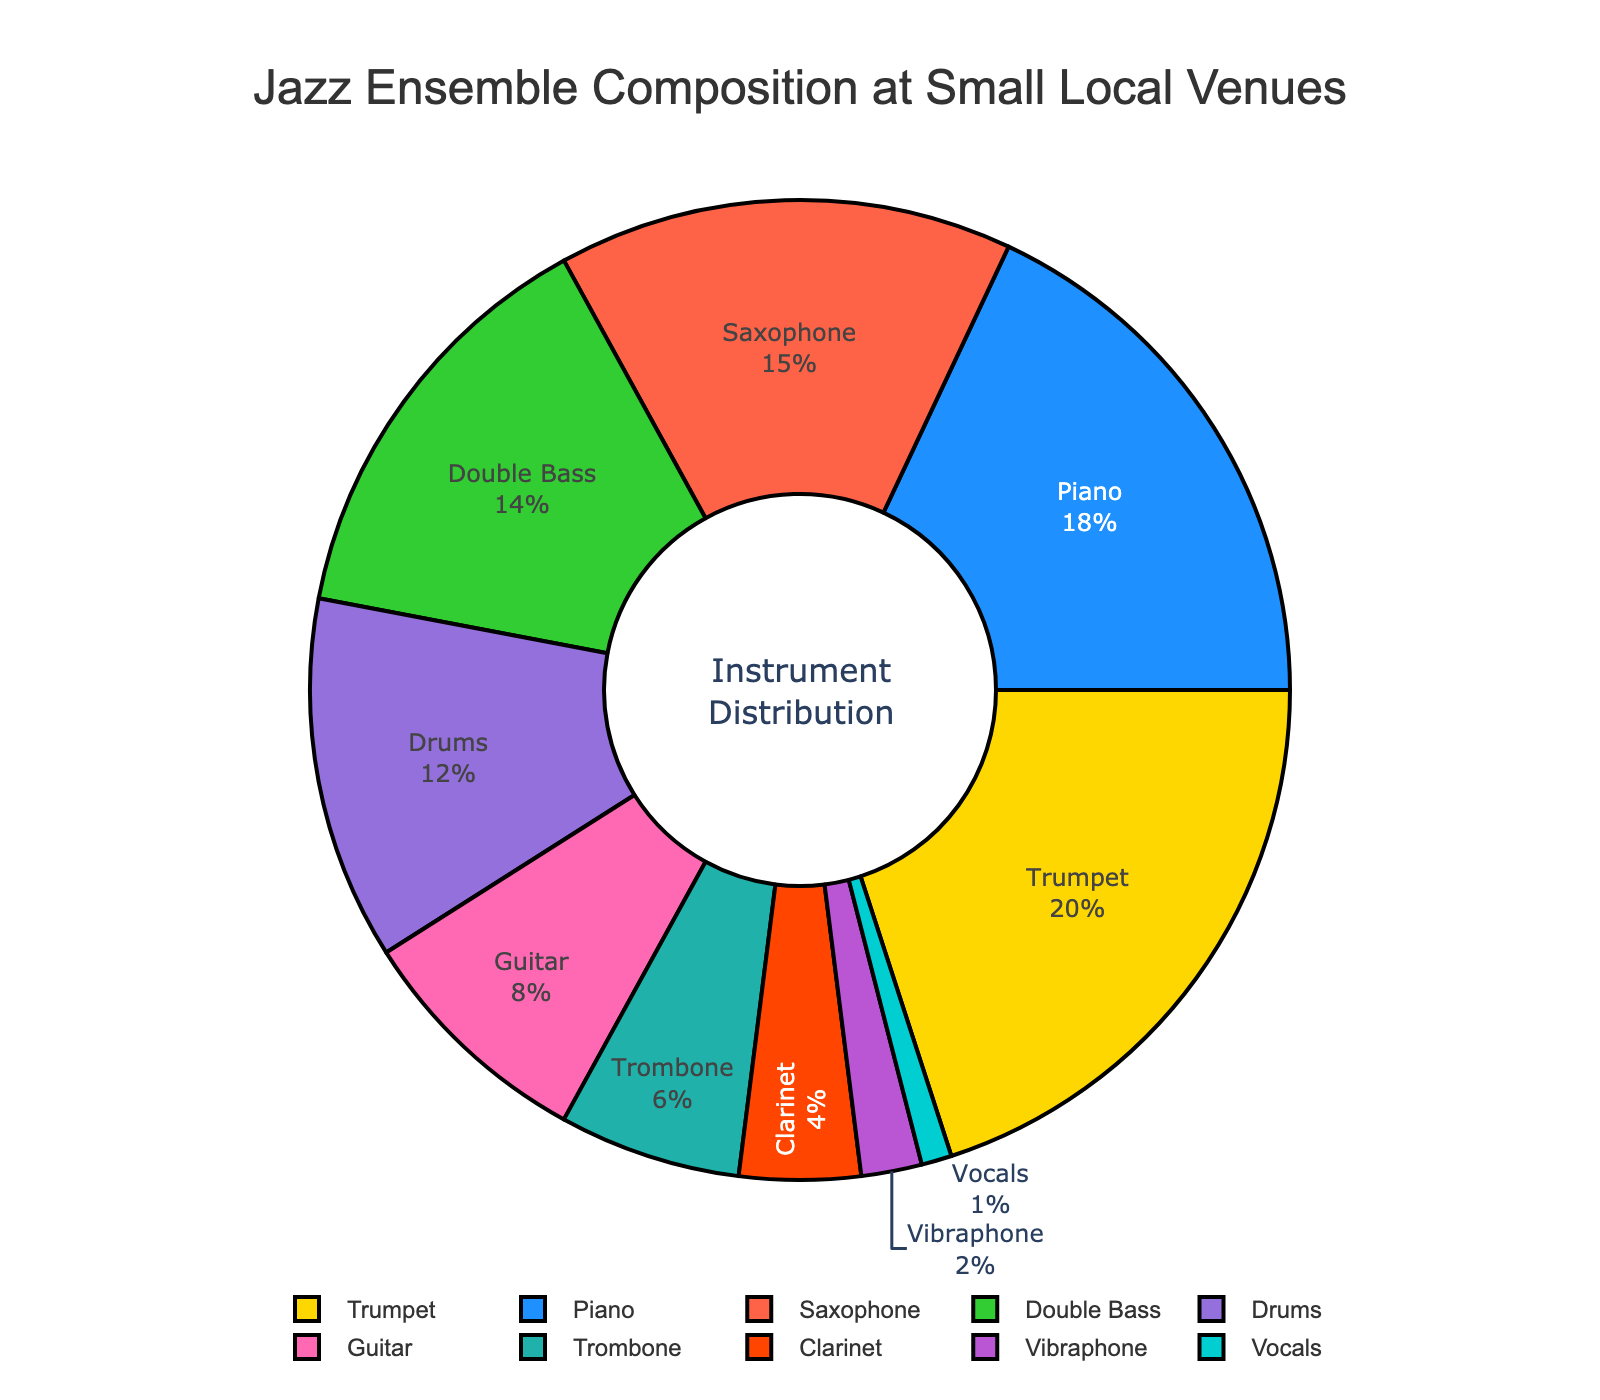Which instrument occupies the largest percentage of a typical jazz ensemble at small local venues? The figure shows the distribution of various instruments in jazz ensembles. The slice labeled "Trumpet" is the largest one.
Answer: Trumpet Which instrument is more common in small local venue jazz ensembles, Saxophone or Drums? By visually comparing the slices, Saxophone has a larger percentage (15%) compared to Drums (12%).
Answer: Saxophone How many instruments collectively account for more than 50% of the ensemble? Summing the percentages of the largest slices until the cumulative percentage exceeds 50%: Trumpet (20%) + Piano (18%) + Saxophone (15%) adds up to 53%. Three instruments account for more than 50%.
Answer: Three What is the difference in percentage between the most common and least common instruments? The most common instrument is Trumpet (20%), and the least common is Vocals (1%). The difference is 20% - 1% = 19%.
Answer: 19% How does the percentage of Guitar compare to that of Trombone? The Guitar accounts for 8% of the ensemble, and Trombone accounts for 6%. Guitar’s percentage is 2% greater than Trombone's.
Answer: 2% Which instruments combined make up approximately one-third of the ensemble? Find a combination of instruments whose total percentage is close to 33%. Double Bass (14%) + Drums (12%) + Guitar (8%) sums up to 34%, which is approximately one-third.
Answer: Double Bass, Drums, Guitar What percentage of the ensemble is made up by Piano and Saxophone together? Adding the percentages of Piano (18%) and Saxophone (15%) gives a total of 33%.
Answer: 33% Are there more woodwind or brass instruments, and by how much? The woodwind instruments are Saxophone (15%), Clarinet (4%), totaling 19%. The brass instruments are Trumpet (20%), Trombone (6%), totaling 26%. Brass instruments have a 7% higher representation.
Answer: Brass by 7% 